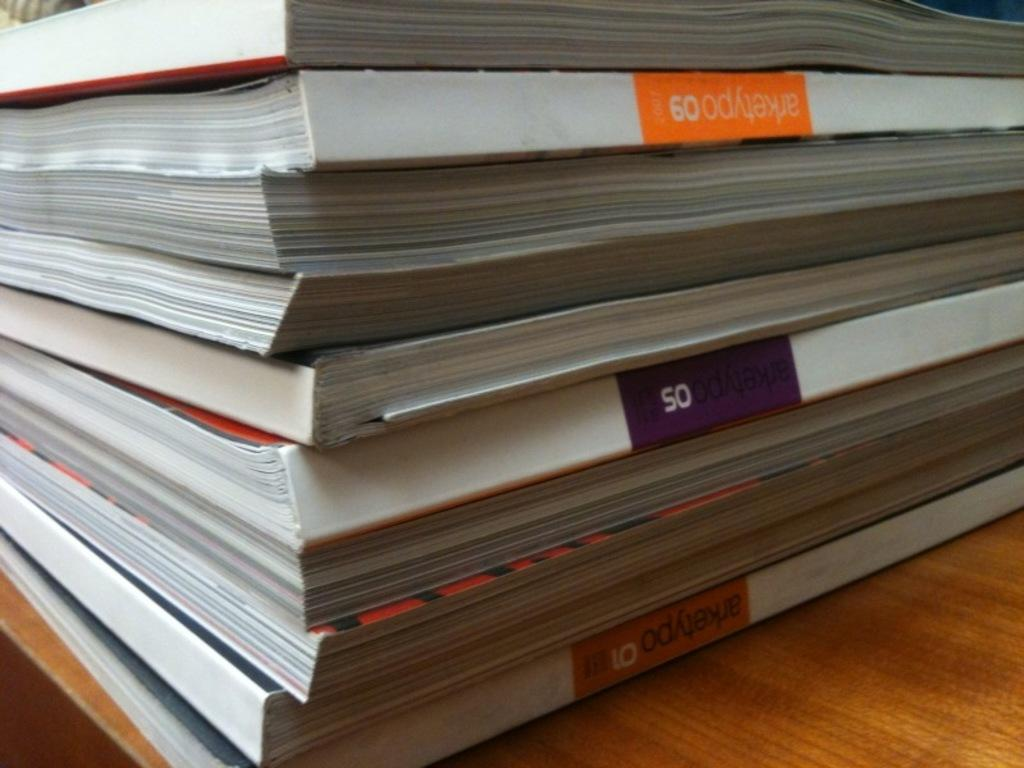<image>
Write a terse but informative summary of the picture. Several books are stacked up on a shelf, including Arketypo 09. 